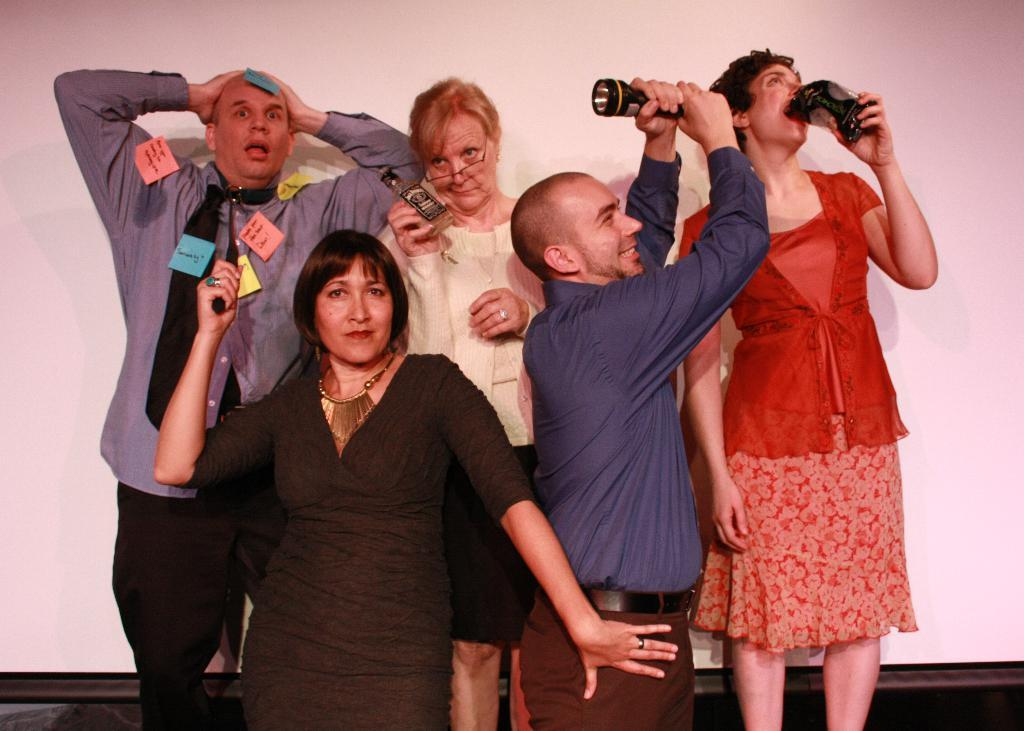What is happening in the image involving a group of people? There is a group of people standing in the image. What are the people holding in the image? The people are holding objects. Can you describe the posture of one of the individuals in the image? There is a person standing with their head held. What can be seen at the back of the image? There is a screen visible at the back of the image. What type of toad can be seen sitting on the screen in the image? There is no toad present in the image; the screen is visible but no toad is sitting on it. 